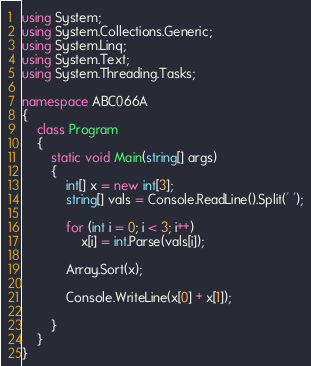<code> <loc_0><loc_0><loc_500><loc_500><_C#_>using System;
using System.Collections.Generic;
using System.Linq;
using System.Text;
using System.Threading.Tasks;

namespace ABC066A
{
    class Program
    {
        static void Main(string[] args)
        {
            int[] x = new int[3];
            string[] vals = Console.ReadLine().Split(' ');

            for (int i = 0; i < 3; i++)
                x[i] = int.Parse(vals[i]);

            Array.Sort(x);

            Console.WriteLine(x[0] + x[1]);

        }
    }
}</code> 